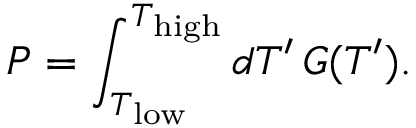Convert formula to latex. <formula><loc_0><loc_0><loc_500><loc_500>P = \int _ { T _ { l o w } } ^ { T _ { h i g h } } d T ^ { \prime } G ( T ^ { \prime } ) .</formula> 